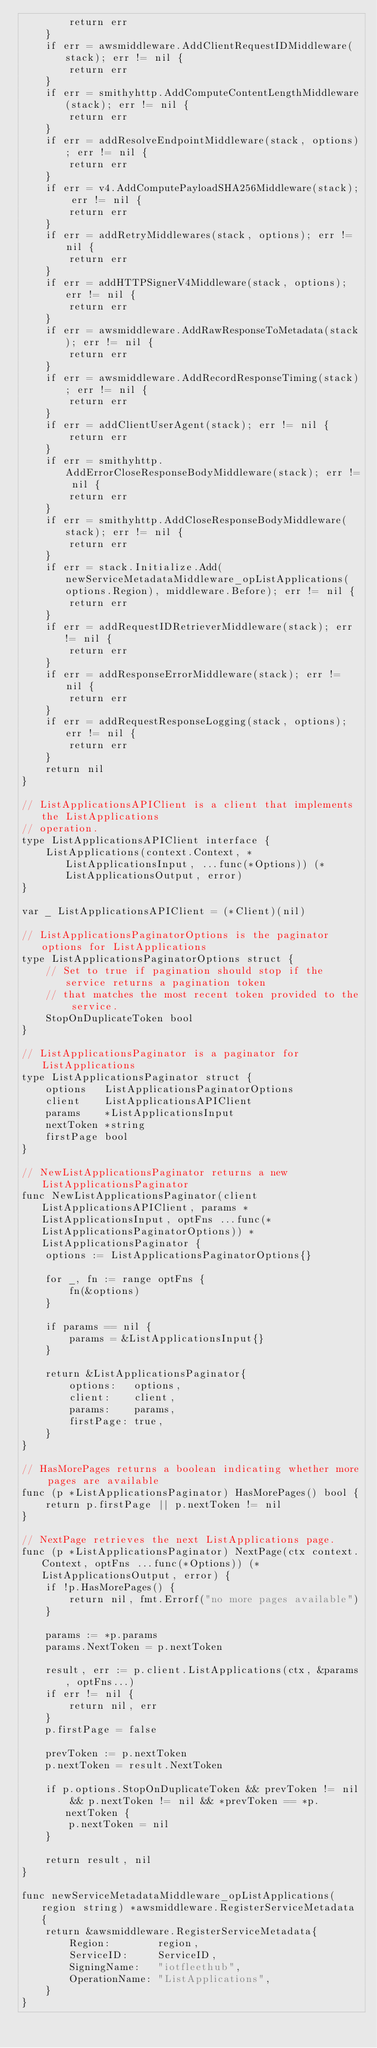Convert code to text. <code><loc_0><loc_0><loc_500><loc_500><_Go_>		return err
	}
	if err = awsmiddleware.AddClientRequestIDMiddleware(stack); err != nil {
		return err
	}
	if err = smithyhttp.AddComputeContentLengthMiddleware(stack); err != nil {
		return err
	}
	if err = addResolveEndpointMiddleware(stack, options); err != nil {
		return err
	}
	if err = v4.AddComputePayloadSHA256Middleware(stack); err != nil {
		return err
	}
	if err = addRetryMiddlewares(stack, options); err != nil {
		return err
	}
	if err = addHTTPSignerV4Middleware(stack, options); err != nil {
		return err
	}
	if err = awsmiddleware.AddRawResponseToMetadata(stack); err != nil {
		return err
	}
	if err = awsmiddleware.AddRecordResponseTiming(stack); err != nil {
		return err
	}
	if err = addClientUserAgent(stack); err != nil {
		return err
	}
	if err = smithyhttp.AddErrorCloseResponseBodyMiddleware(stack); err != nil {
		return err
	}
	if err = smithyhttp.AddCloseResponseBodyMiddleware(stack); err != nil {
		return err
	}
	if err = stack.Initialize.Add(newServiceMetadataMiddleware_opListApplications(options.Region), middleware.Before); err != nil {
		return err
	}
	if err = addRequestIDRetrieverMiddleware(stack); err != nil {
		return err
	}
	if err = addResponseErrorMiddleware(stack); err != nil {
		return err
	}
	if err = addRequestResponseLogging(stack, options); err != nil {
		return err
	}
	return nil
}

// ListApplicationsAPIClient is a client that implements the ListApplications
// operation.
type ListApplicationsAPIClient interface {
	ListApplications(context.Context, *ListApplicationsInput, ...func(*Options)) (*ListApplicationsOutput, error)
}

var _ ListApplicationsAPIClient = (*Client)(nil)

// ListApplicationsPaginatorOptions is the paginator options for ListApplications
type ListApplicationsPaginatorOptions struct {
	// Set to true if pagination should stop if the service returns a pagination token
	// that matches the most recent token provided to the service.
	StopOnDuplicateToken bool
}

// ListApplicationsPaginator is a paginator for ListApplications
type ListApplicationsPaginator struct {
	options   ListApplicationsPaginatorOptions
	client    ListApplicationsAPIClient
	params    *ListApplicationsInput
	nextToken *string
	firstPage bool
}

// NewListApplicationsPaginator returns a new ListApplicationsPaginator
func NewListApplicationsPaginator(client ListApplicationsAPIClient, params *ListApplicationsInput, optFns ...func(*ListApplicationsPaginatorOptions)) *ListApplicationsPaginator {
	options := ListApplicationsPaginatorOptions{}

	for _, fn := range optFns {
		fn(&options)
	}

	if params == nil {
		params = &ListApplicationsInput{}
	}

	return &ListApplicationsPaginator{
		options:   options,
		client:    client,
		params:    params,
		firstPage: true,
	}
}

// HasMorePages returns a boolean indicating whether more pages are available
func (p *ListApplicationsPaginator) HasMorePages() bool {
	return p.firstPage || p.nextToken != nil
}

// NextPage retrieves the next ListApplications page.
func (p *ListApplicationsPaginator) NextPage(ctx context.Context, optFns ...func(*Options)) (*ListApplicationsOutput, error) {
	if !p.HasMorePages() {
		return nil, fmt.Errorf("no more pages available")
	}

	params := *p.params
	params.NextToken = p.nextToken

	result, err := p.client.ListApplications(ctx, &params, optFns...)
	if err != nil {
		return nil, err
	}
	p.firstPage = false

	prevToken := p.nextToken
	p.nextToken = result.NextToken

	if p.options.StopOnDuplicateToken && prevToken != nil && p.nextToken != nil && *prevToken == *p.nextToken {
		p.nextToken = nil
	}

	return result, nil
}

func newServiceMetadataMiddleware_opListApplications(region string) *awsmiddleware.RegisterServiceMetadata {
	return &awsmiddleware.RegisterServiceMetadata{
		Region:        region,
		ServiceID:     ServiceID,
		SigningName:   "iotfleethub",
		OperationName: "ListApplications",
	}
}
</code> 